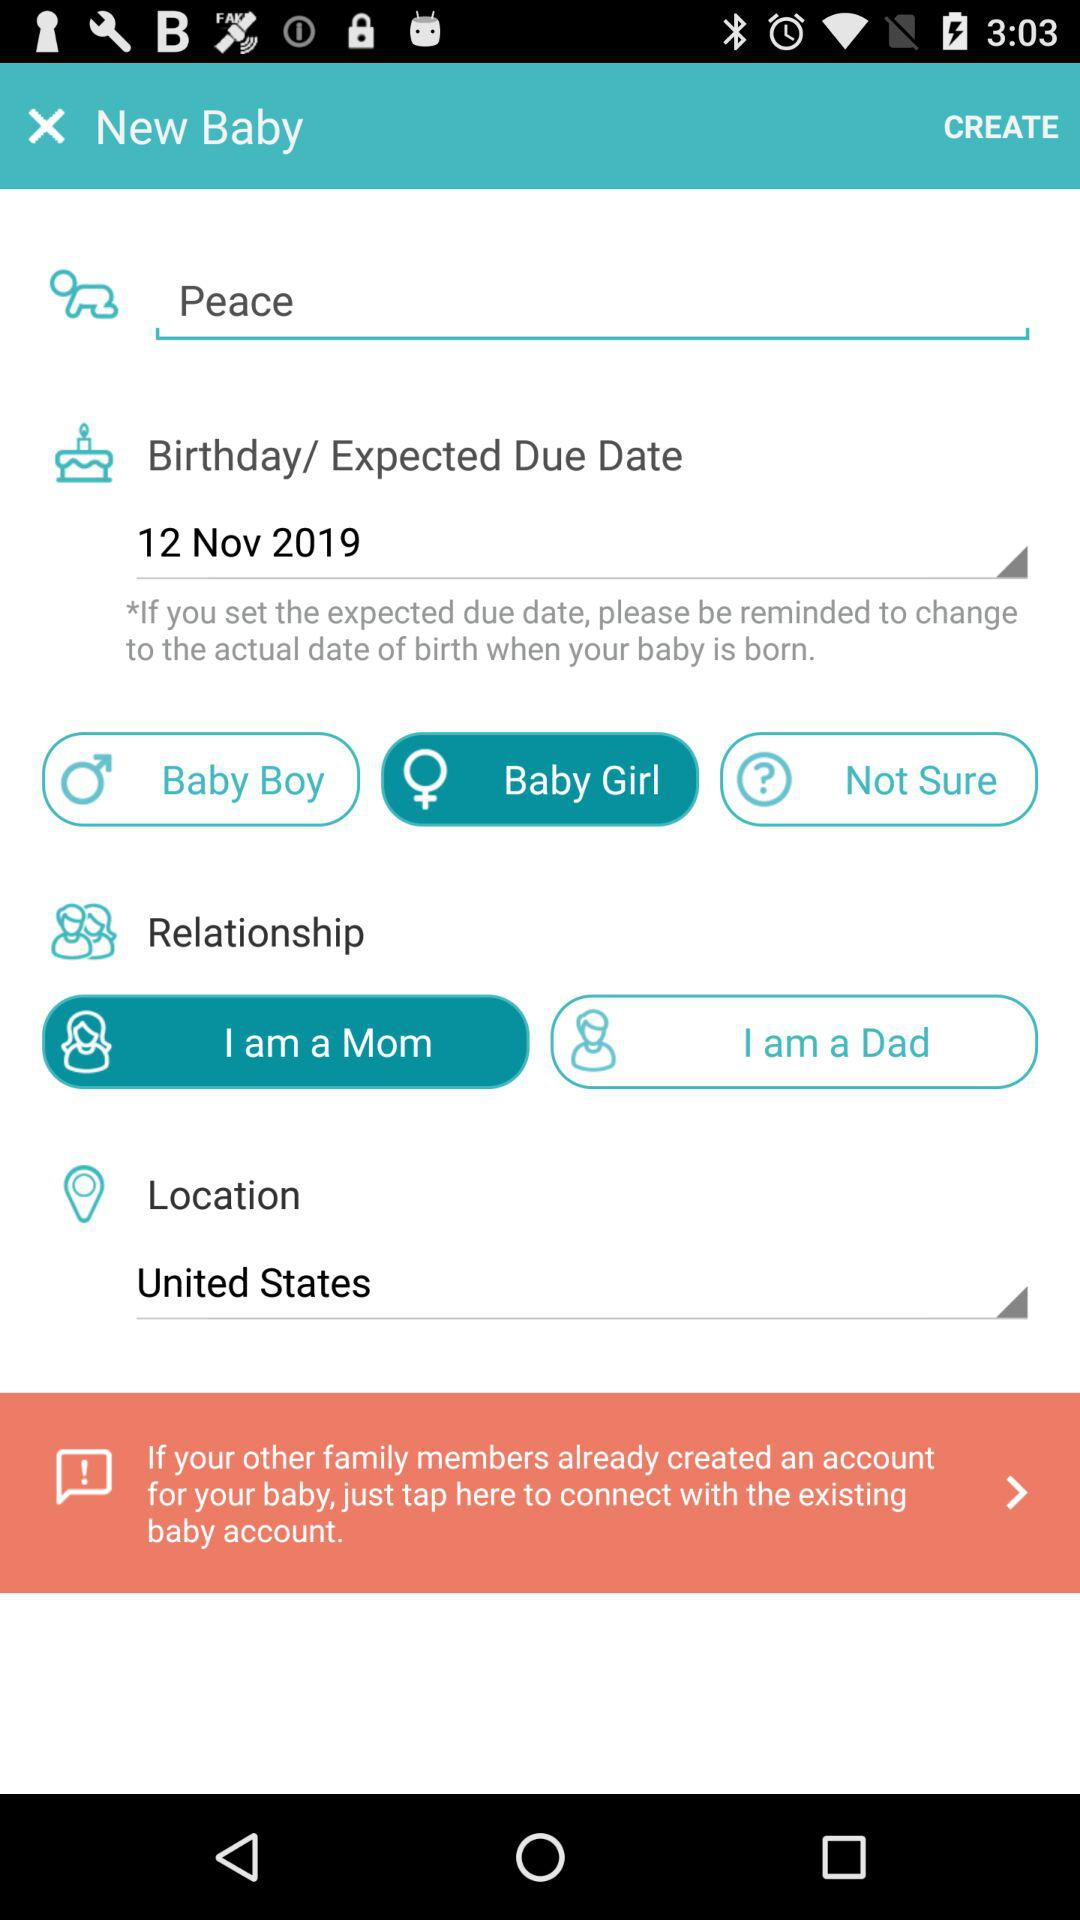What is the location? The location is the United States. 